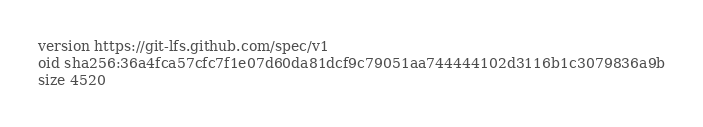<code> <loc_0><loc_0><loc_500><loc_500><_HTML_>version https://git-lfs.github.com/spec/v1
oid sha256:36a4fca57cfc7f1e07d60da81dcf9c79051aa744444102d3116b1c3079836a9b
size 4520
</code> 